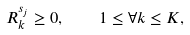<formula> <loc_0><loc_0><loc_500><loc_500>R ^ { s _ { j } } _ { k } \geq 0 , \quad 1 \leq \forall k \leq K ,</formula> 